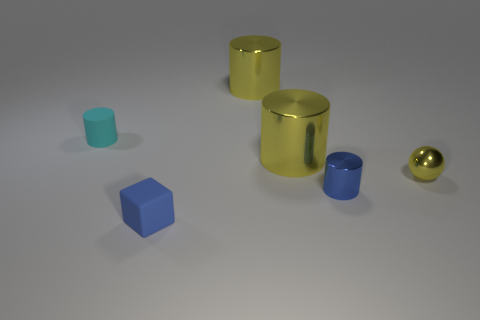Add 3 brown metallic blocks. How many objects exist? 9 Subtract all small blue shiny cylinders. How many cylinders are left? 3 Subtract all cyan blocks. How many blue balls are left? 0 Subtract all blue cylinders. How many cylinders are left? 3 Subtract 1 cylinders. How many cylinders are left? 3 Subtract all purple cylinders. Subtract all green blocks. How many cylinders are left? 4 Subtract 0 red cubes. How many objects are left? 6 Subtract all cylinders. How many objects are left? 2 Subtract all blue things. Subtract all yellow metallic cylinders. How many objects are left? 2 Add 3 tiny metallic spheres. How many tiny metallic spheres are left? 4 